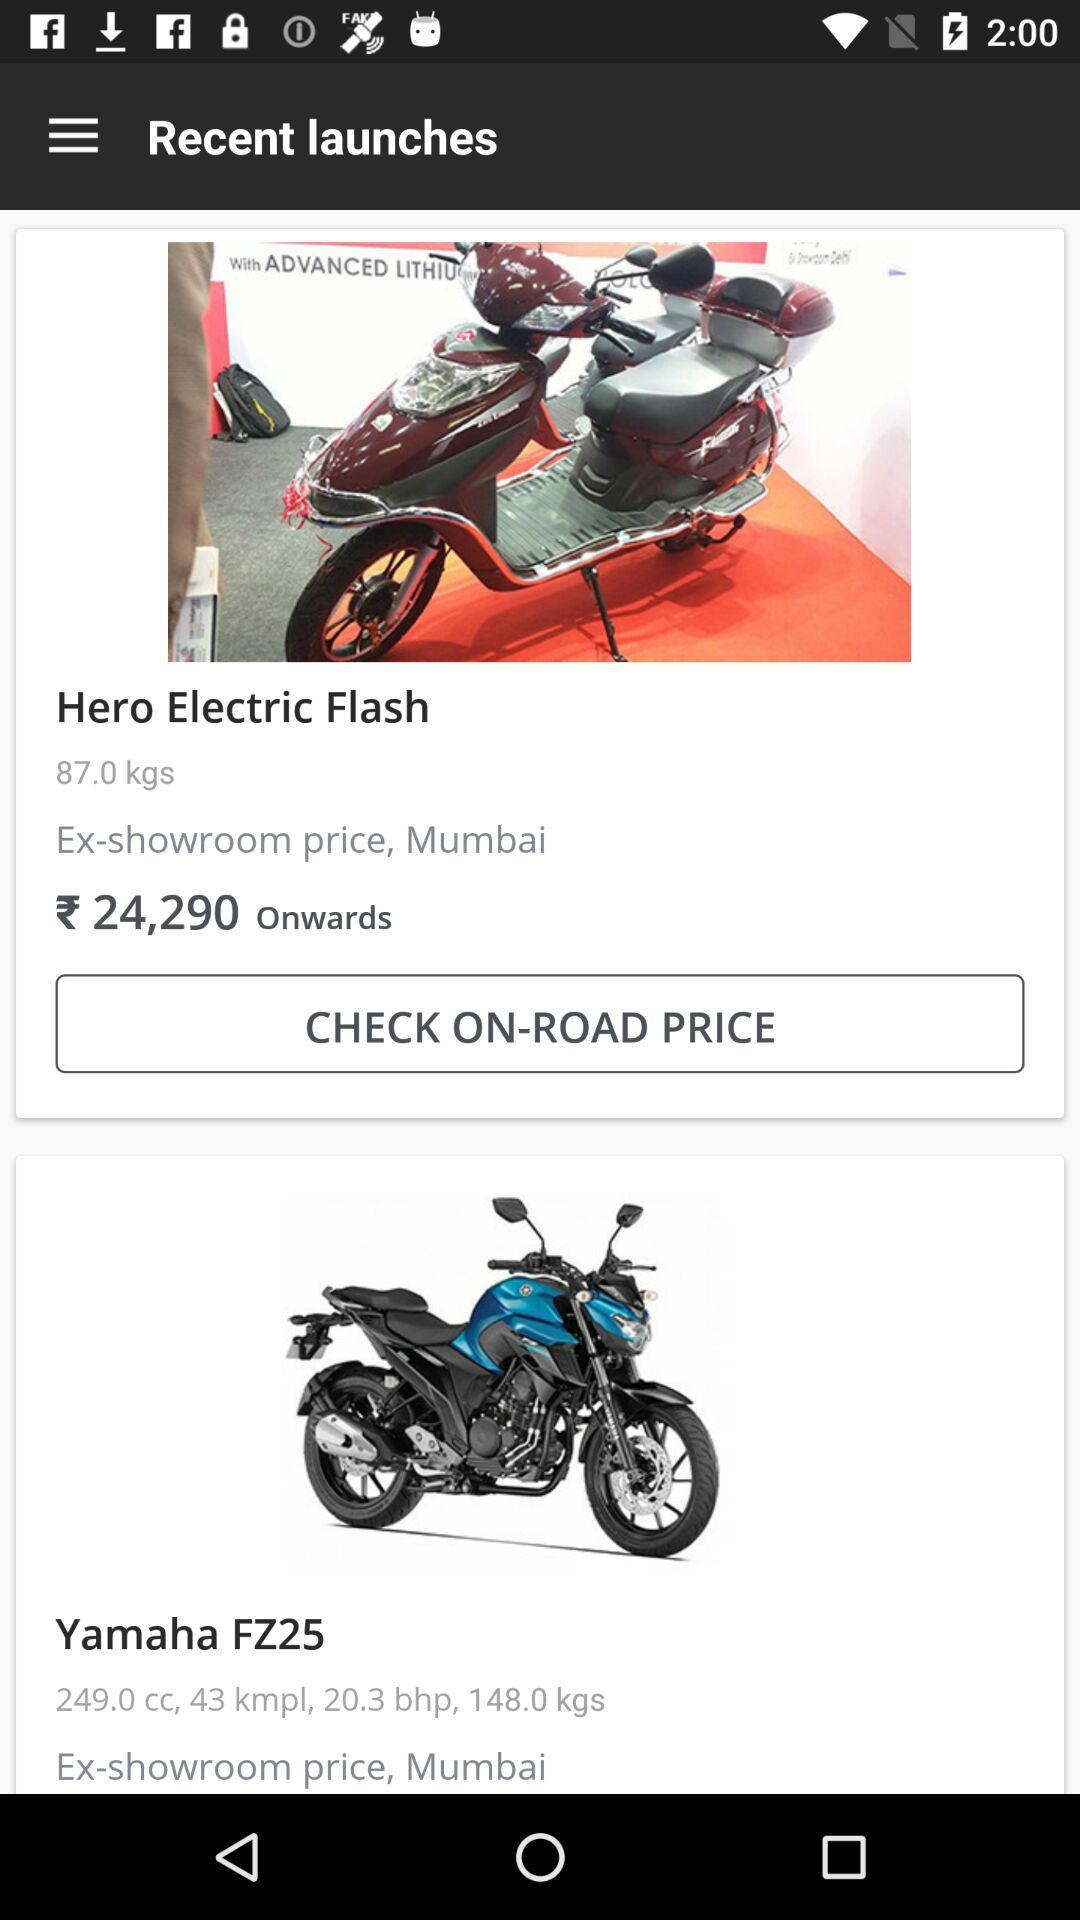How much cc is in a "Yamaha FZ25"? A "Yamaha FZ25" has a 249 cc engine. 